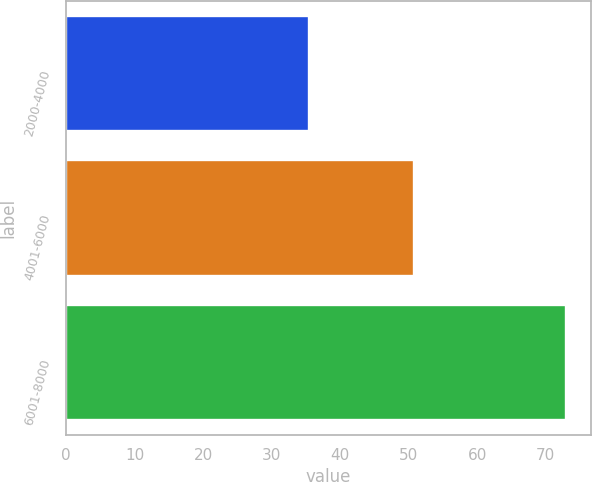Convert chart. <chart><loc_0><loc_0><loc_500><loc_500><bar_chart><fcel>2000-4000<fcel>4001-6000<fcel>6001-8000<nl><fcel>35.4<fcel>50.8<fcel>72.95<nl></chart> 